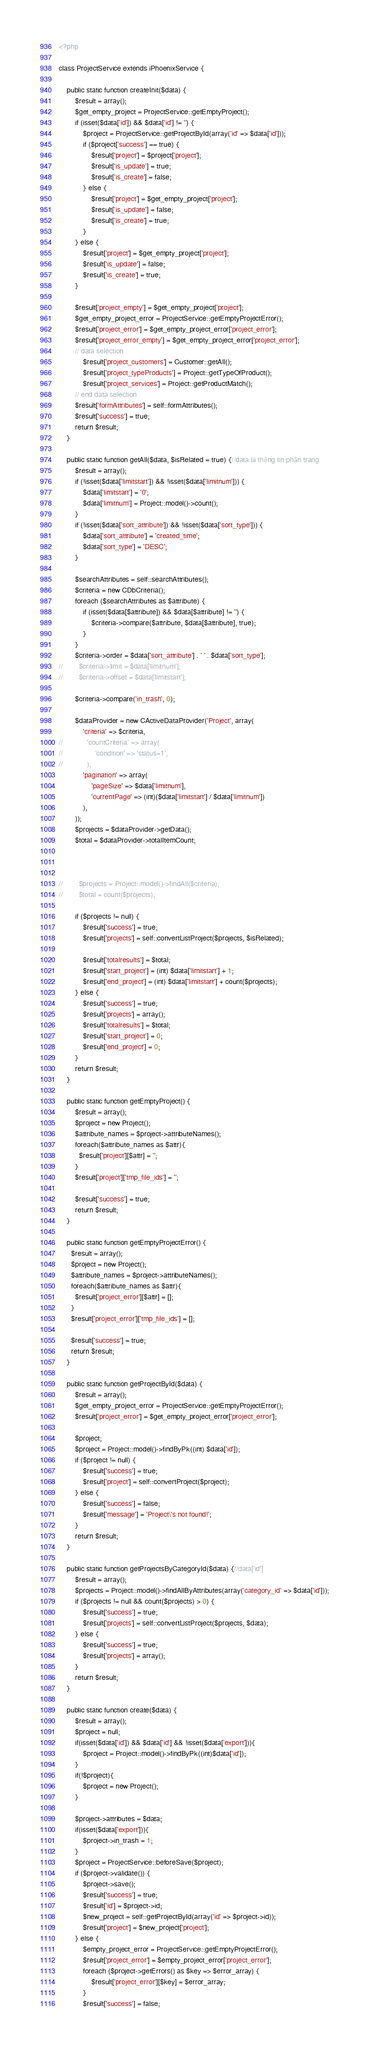Convert code to text. <code><loc_0><loc_0><loc_500><loc_500><_PHP_><?php

class ProjectService extends iPhoenixService {

    public static function createInit($data) {
        $result = array();
        $get_empty_project = ProjectService::getEmptyProject();
        if (isset($data['id']) && $data['id'] != '') {
            $project = ProjectService::getProjectById(array('id' => $data['id']));
            if ($project['success'] == true) {
                $result['project'] = $project['project'];
                $result['is_update'] = true;
                $result['is_create'] = false;
            } else {
                $result['project'] = $get_empty_project['project'];
                $result['is_update'] = false;
                $result['is_create'] = true;
            }
        } else {
            $result['project'] = $get_empty_project['project'];
            $result['is_update'] = false;
            $result['is_create'] = true;
        }

        $result['project_empty'] = $get_empty_project['project'];
        $get_empty_project_error = ProjectService::getEmptyProjectError();
        $result['project_error'] = $get_empty_project_error['project_error'];
        $result['project_error_empty'] = $get_empty_project_error['project_error'];
        // data selection
            $result['project_customers'] = Customer::getAll();
            $result['project_typeProducts'] = Project::getTypeOfProduct();
            $result['project_services'] = Project::getProductMatch();
        // end data selection
        $result['formAttributes'] = self::formAttributes();
        $result['success'] = true;
        return $result;
    }

    public static function getAll($data, $isRelated = true) {//data là thông tin phân trang
        $result = array();
        if (!isset($data['limitstart']) && !isset($data['limitnum'])) {
            $data['limitstart'] = '0';
            $data['limitnum'] = Project::model()->count();
        }
        if (!isset($data['sort_attribute']) && !isset($data['sort_type'])) {
            $data['sort_attribute'] = 'created_time';
            $data['sort_type'] = 'DESC';
        }
        
        $searchAttributes = self::searchAttributes();
        $criteria = new CDbCriteria();
        foreach ($searchAttributes as $attribute) {
            if (isset($data[$attribute]) && $data[$attribute] != '') {
                $criteria->compare($attribute, $data[$attribute], true);
            }
        }
        $criteria->order = $data['sort_attribute'] . ' ' . $data['sort_type'];
//        $criteria->limit = $data['limitnum'];
//        $criteria->offset = $data['limitstart'];
        
        $criteria->compare('in_trash', 0);
        
        $dataProvider = new CActiveDataProvider('Project', array(
            'criteria' => $criteria,
//            'countCriteria' => array(
//                'condition' => 'status=1',
//            ),
            'pagination' => array(
                'pageSize' => $data['limitnum'],
                'currentPage' => (int)($data['limitstart'] / $data['limitnum'])
            ),
        ));
        $projects = $dataProvider->getData();
        $total = $dataProvider->totalItemCount;



//        $projects = Project::model()->findAll($criteria);
//        $total = count($projects);

        if ($projects != null) {
            $result['success'] = true;
            $result['projects'] = self::convertListProject($projects, $isRelated);

            $result['totalresults'] = $total;
            $result['start_project'] = (int) $data['limitstart'] + 1;
            $result['end_project'] = (int) $data['limitstart'] + count($projects);
        } else {
            $result['success'] = true;
            $result['projects'] = array();
            $result['totalresults'] = $total;
            $result['start_project'] = 0;
            $result['end_project'] = 0;
        }
        return $result;
    }

    public static function getEmptyProject() {
        $result = array();
        $project = new Project();
        $attribute_names = $project->attributeNames();
        foreach($attribute_names as $attr){
          $result['project'][$attr] = '';
        }
        $result['project']['tmp_file_ids'] = '';

        $result['success'] = true;
        return $result;
    }

    public static function getEmptyProjectError() {
      $result = array();
      $project = new Project();
      $attribute_names = $project->attributeNames();
      foreach($attribute_names as $attr){
        $result['project_error'][$attr] = [];
      }
      $result['project_error']['tmp_file_ids'] = [];

      $result['success'] = true;
      return $result;
    }

    public static function getProjectById($data) {
        $result = array();
        $get_empty_project_error = ProjectService::getEmptyProjectError();
        $result['project_error'] = $get_empty_project_error['project_error'];

        $project;
        $project = Project::model()->findByPk((int) $data['id']);
        if ($project != null) {
            $result['success'] = true;
            $result['project'] = self::convertProject($project);
        } else {
            $result['success'] = false;
            $result['message'] = 'Project\'s not found!';
        }
        return $result;
    }

    public static function getProjectsByCategoryId($data) {//data['id']
        $result = array();
        $projects = Project::model()->findAllByAttributes(array('category_id' => $data['id']));
        if ($projects != null && count($projects) > 0) {
            $result['success'] = true;
            $result['projects'] = self::convertListProject($projects, $data);
        } else {
            $result['success'] = true;
            $result['projects'] = array();
        }
        return $result;
    }

    public static function create($data) {
        $result = array();
        $project = null;
        if(isset($data['id']) && $data['id'] && !isset($data['export'])){
            $project = Project::model()->findByPk((int)$data['id']);
        }
        if(!$project){
            $project = new Project();
        }

        $project->attributes = $data;
        if(isset($data['export'])){
            $project->in_trash = 1;
        }
        $project = ProjectService::beforeSave($project);
        if ($project->validate()) {
            $project->save();
            $result['success'] = true;
            $result['id'] = $project->id;
            $new_project = self::getProjectById(array('id' => $project->id));
            $result['project'] = $new_project['project'];
        } else {
            $empty_project_error = ProjectService::getEmptyProjectError();
            $result['project_error'] = $empty_project_error['project_error'];
            foreach ($project->getErrors() as $key => $error_array) {
                $result['project_error'][$key] = $error_array;
            }
            $result['success'] = false;</code> 